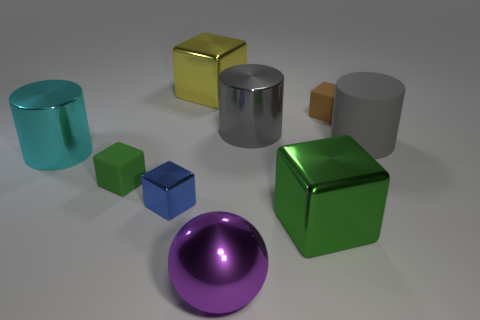Does the tiny rubber object that is in front of the big matte thing have the same shape as the small matte thing behind the large cyan metal cylinder?
Give a very brief answer. Yes. Is there a tiny brown object that has the same material as the large yellow block?
Provide a succinct answer. No. Do the cube that is behind the brown matte block and the cyan cylinder have the same material?
Ensure brevity in your answer.  Yes. Are there more tiny metallic cubes in front of the large purple ball than tiny metallic cubes that are in front of the blue block?
Keep it short and to the point. No. The rubber thing that is the same size as the cyan shiny cylinder is what color?
Offer a very short reply. Gray. Are there any metallic objects of the same color as the sphere?
Make the answer very short. No. There is a large cylinder in front of the large matte object; is it the same color as the tiny matte cube that is behind the gray rubber thing?
Your response must be concise. No. What is the large cylinder behind the large matte cylinder made of?
Provide a short and direct response. Metal. The small cube that is made of the same material as the big yellow thing is what color?
Provide a succinct answer. Blue. How many metal cylinders are the same size as the cyan object?
Offer a very short reply. 1. 